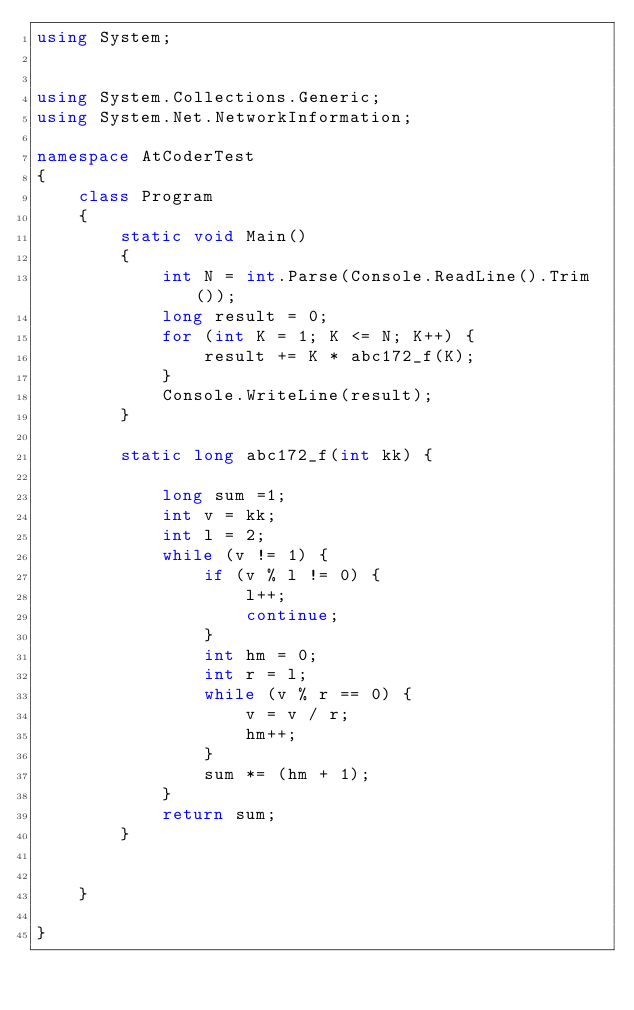Convert code to text. <code><loc_0><loc_0><loc_500><loc_500><_C#_>using System;


using System.Collections.Generic;
using System.Net.NetworkInformation;

namespace AtCoderTest
{
    class Program
    {
        static void Main()
        {
            int N = int.Parse(Console.ReadLine().Trim());
            long result = 0;
            for (int K = 1; K <= N; K++) {
                result += K * abc172_f(K);
            }
            Console.WriteLine(result);
        }

        static long abc172_f(int kk) {
            
            long sum =1;
            int v = kk;
            int l = 2;
            while (v != 1) {
                if (v % l != 0) {
                    l++;
                    continue;
                }
                int hm = 0;
                int r = l;
                while (v % r == 0) {
                    v = v / r;
                    hm++;
                }
                sum *= (hm + 1);
            }
            return sum;
        }


    }

}
</code> 